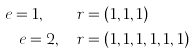<formula> <loc_0><loc_0><loc_500><loc_500>e = 1 , \quad & r = ( 1 , 1 , 1 ) \\ e = 2 , \quad & r = ( 1 , 1 , 1 , 1 , 1 , 1 )</formula> 